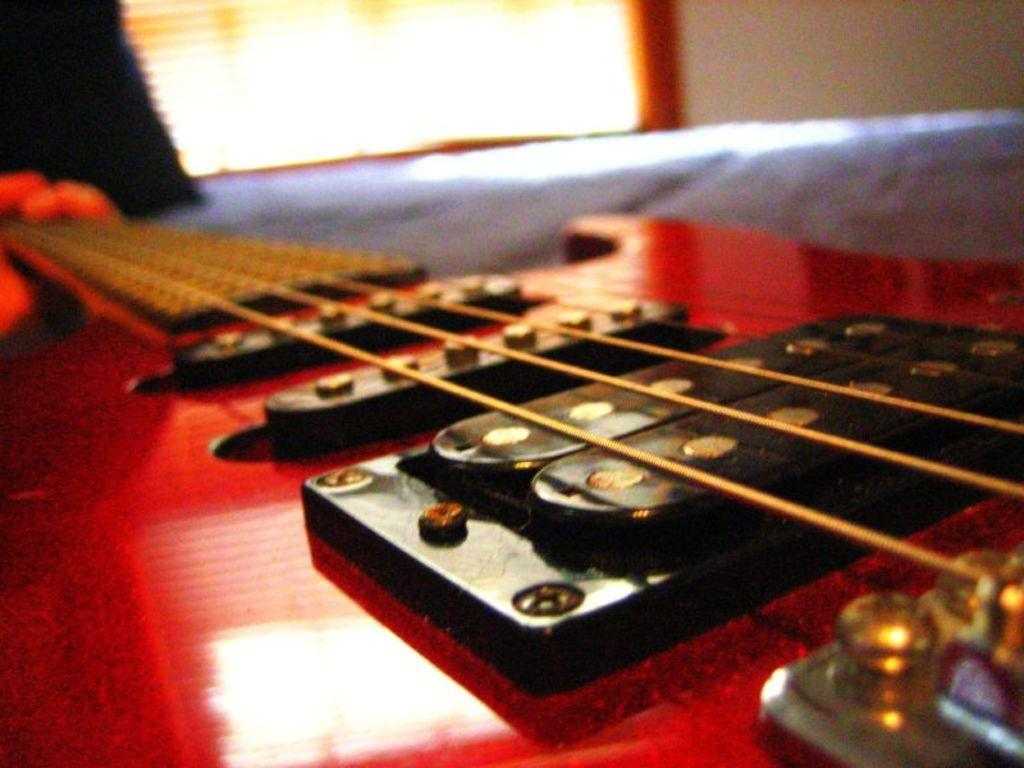What musical instrument is present in the image? There is a guitar in the image. What feature of the guitar is mentioned in the facts? The guitar has strings. What can be seen in the background of the image? There is a wall in the background of the image. Who is the owner of the finger seen playing the guitar in the image? There is no finger or person playing the guitar in the image, so it is not possible to determine the owner. 